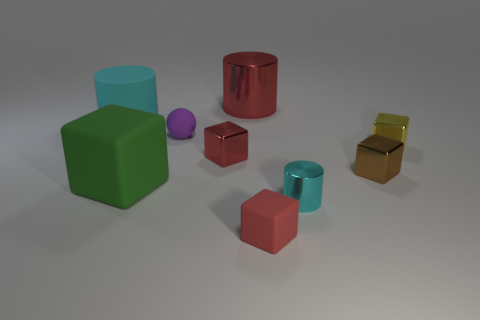Subtract 1 cubes. How many cubes are left? 4 Subtract all green cubes. How many cubes are left? 4 Subtract all large green blocks. How many blocks are left? 4 Subtract all cyan cubes. Subtract all cyan cylinders. How many cubes are left? 5 Add 1 yellow balls. How many objects exist? 10 Subtract all cylinders. How many objects are left? 6 Subtract 0 cyan balls. How many objects are left? 9 Subtract all yellow matte balls. Subtract all tiny metallic objects. How many objects are left? 5 Add 6 tiny purple matte spheres. How many tiny purple matte spheres are left? 7 Add 9 yellow metal cubes. How many yellow metal cubes exist? 10 